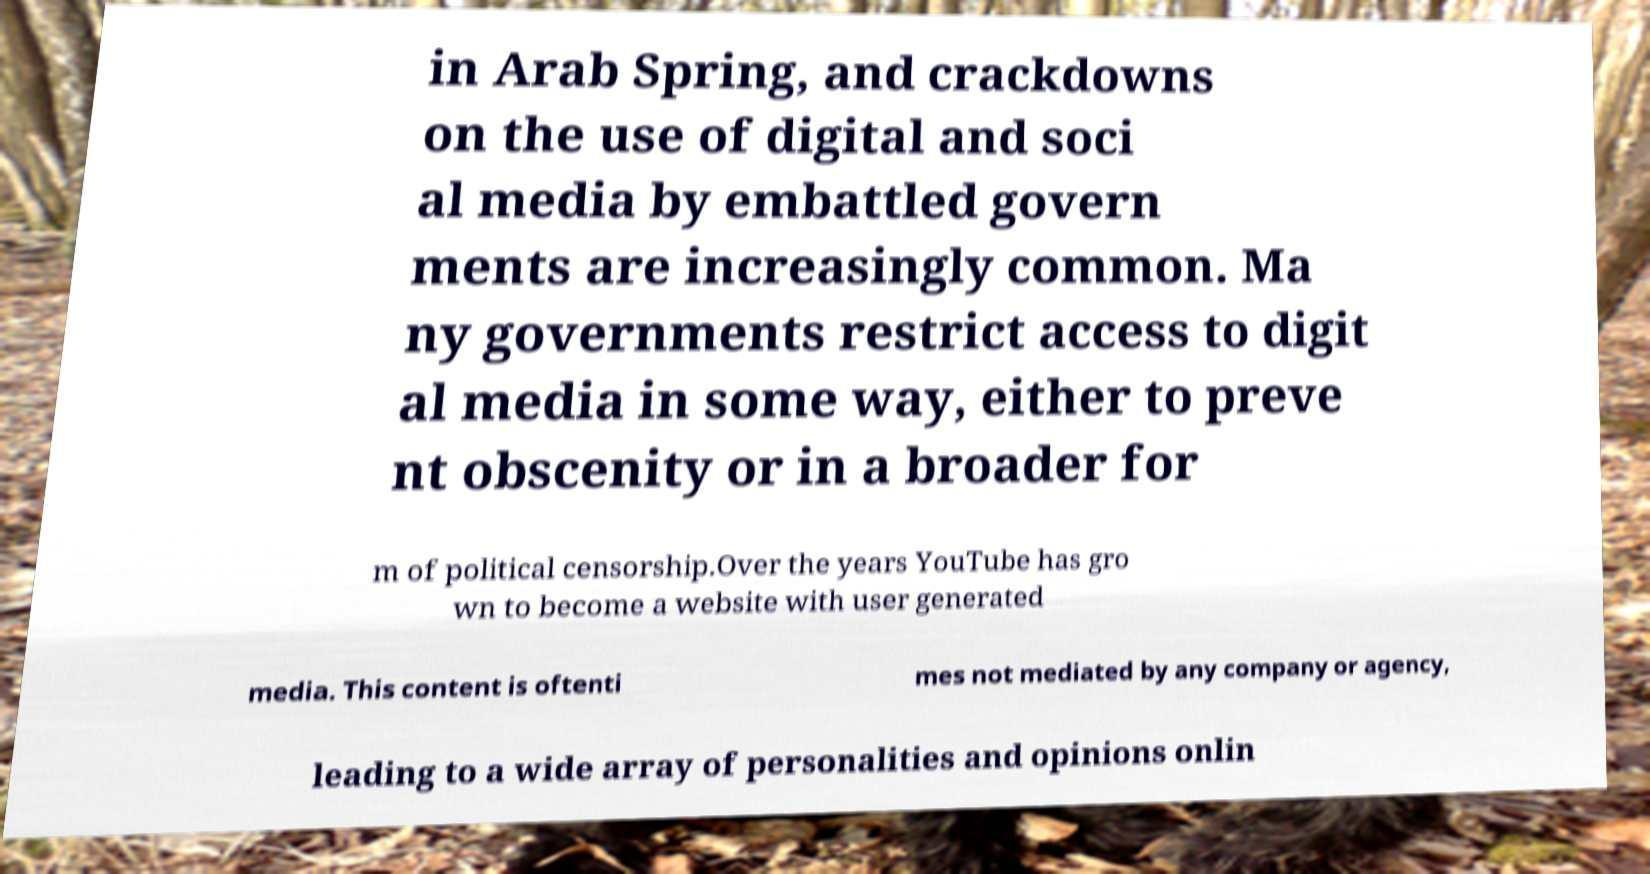Could you extract and type out the text from this image? in Arab Spring, and crackdowns on the use of digital and soci al media by embattled govern ments are increasingly common. Ma ny governments restrict access to digit al media in some way, either to preve nt obscenity or in a broader for m of political censorship.Over the years YouTube has gro wn to become a website with user generated media. This content is oftenti mes not mediated by any company or agency, leading to a wide array of personalities and opinions onlin 